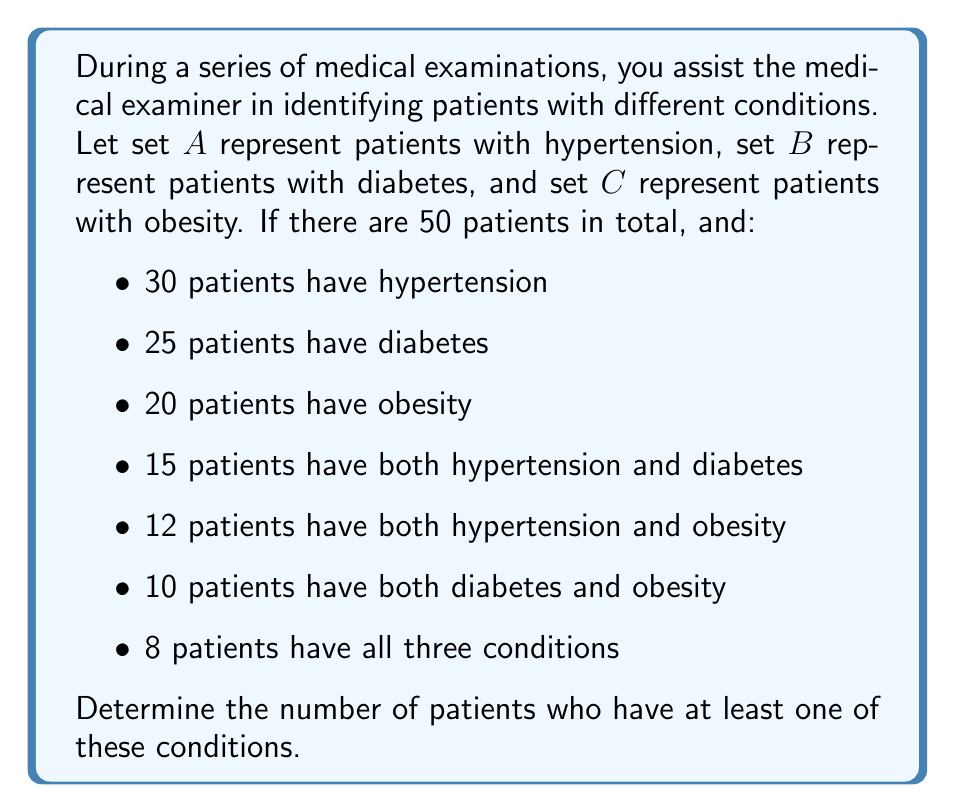Can you solve this math problem? To solve this problem, we can use the principle of inclusion-exclusion for three sets. Let's break it down step-by-step:

1) First, we need to find $|A \cup B \cup C|$, which represents the number of patients with at least one condition.

2) The formula for three sets is:

   $$|A \cup B \cup C| = |A| + |B| + |C| - |A \cap B| - |A \cap C| - |B \cap C| + |A \cap B \cap C|$$

3) We are given:
   $|A| = 30$ (hypertension)
   $|B| = 25$ (diabetes)
   $|C| = 20$ (obesity)
   $|A \cap B| = 15$ (hypertension and diabetes)
   $|A \cap C| = 12$ (hypertension and obesity)
   $|B \cap C| = 10$ (diabetes and obesity)
   $|A \cap B \cap C| = 8$ (all three conditions)

4) Let's substitute these values into our formula:

   $$|A \cup B \cup C| = 30 + 25 + 20 - 15 - 12 - 10 + 8$$

5) Now we can calculate:

   $$|A \cup B \cup C| = 75 - 37 + 8 = 46$$

Therefore, 46 patients have at least one of these conditions.
Answer: 46 patients 